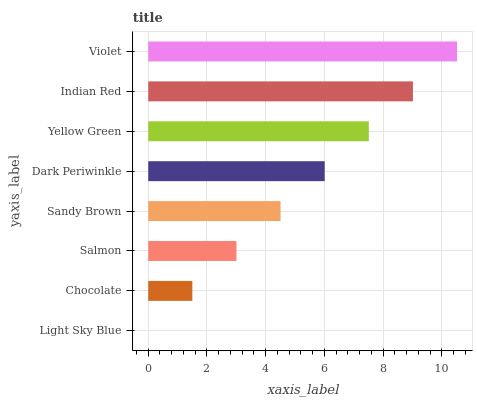Is Light Sky Blue the minimum?
Answer yes or no. Yes. Is Violet the maximum?
Answer yes or no. Yes. Is Chocolate the minimum?
Answer yes or no. No. Is Chocolate the maximum?
Answer yes or no. No. Is Chocolate greater than Light Sky Blue?
Answer yes or no. Yes. Is Light Sky Blue less than Chocolate?
Answer yes or no. Yes. Is Light Sky Blue greater than Chocolate?
Answer yes or no. No. Is Chocolate less than Light Sky Blue?
Answer yes or no. No. Is Dark Periwinkle the high median?
Answer yes or no. Yes. Is Sandy Brown the low median?
Answer yes or no. Yes. Is Sandy Brown the high median?
Answer yes or no. No. Is Light Sky Blue the low median?
Answer yes or no. No. 